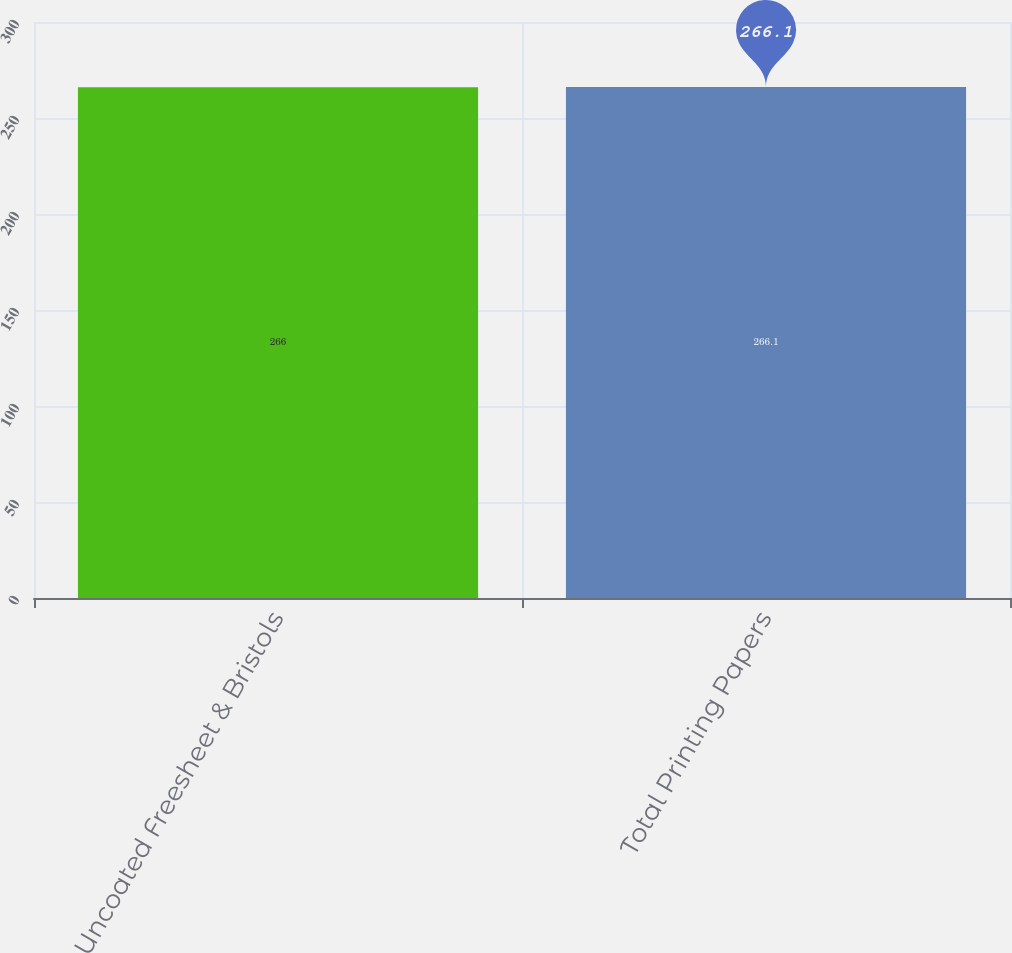<chart> <loc_0><loc_0><loc_500><loc_500><bar_chart><fcel>Uncoated Freesheet & Bristols<fcel>Total Printing Papers<nl><fcel>266<fcel>266.1<nl></chart> 